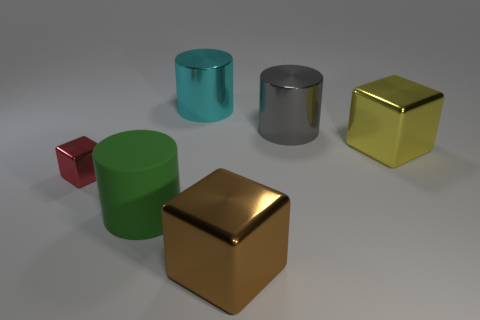Is there anything else that has the same size as the red thing?
Offer a very short reply. No. There is a green object in front of the shiny block on the left side of the metallic object that is in front of the tiny red thing; what shape is it?
Offer a very short reply. Cylinder. What is the shape of the big object left of the shiny cylinder on the left side of the brown metal cube?
Your answer should be very brief. Cylinder. Is there a small cube that has the same material as the large gray cylinder?
Give a very brief answer. Yes. What number of cyan objects are either large shiny cylinders or matte cylinders?
Give a very brief answer. 1. There is a gray object that is made of the same material as the big cyan cylinder; what is its size?
Your answer should be very brief. Large. How many cylinders are either big green shiny things or large brown things?
Your response must be concise. 0. Is the number of big green matte cylinders greater than the number of big cubes?
Ensure brevity in your answer.  No. How many other gray metallic cylinders are the same size as the gray cylinder?
Keep it short and to the point. 0. What number of things are metal things that are behind the big yellow object or brown things?
Provide a succinct answer. 3. 